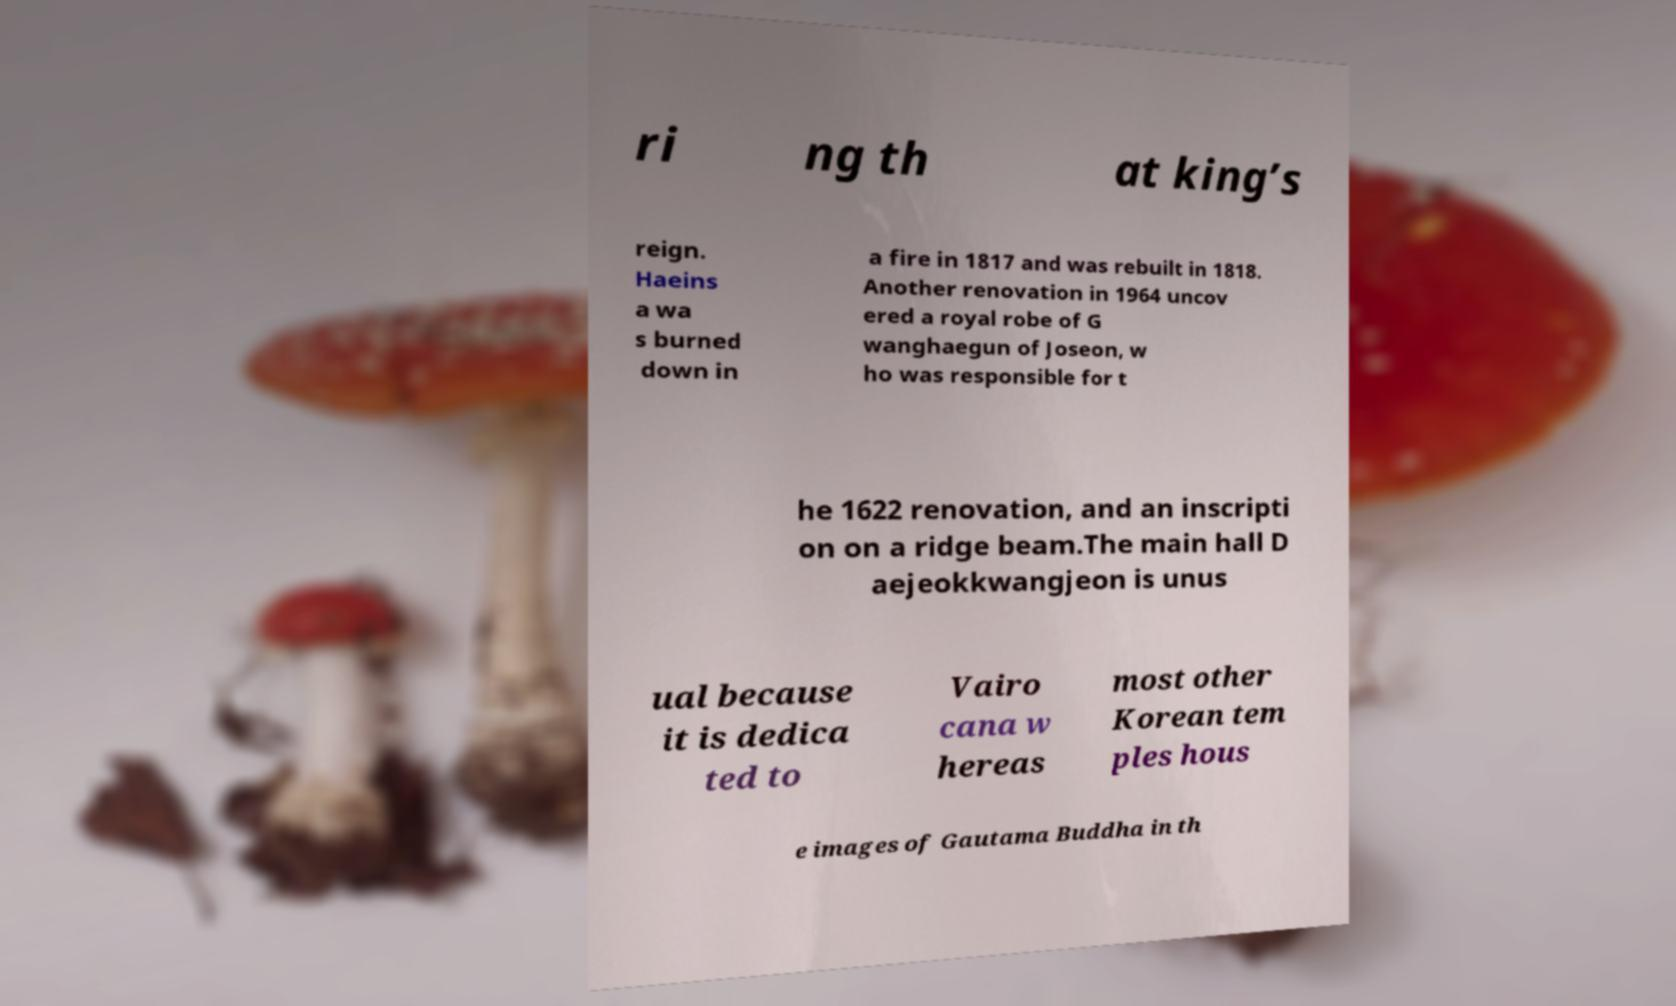Please identify and transcribe the text found in this image. ri ng th at king’s reign. Haeins a wa s burned down in a fire in 1817 and was rebuilt in 1818. Another renovation in 1964 uncov ered a royal robe of G wanghaegun of Joseon, w ho was responsible for t he 1622 renovation, and an inscripti on on a ridge beam.The main hall D aejeokkwangjeon is unus ual because it is dedica ted to Vairo cana w hereas most other Korean tem ples hous e images of Gautama Buddha in th 